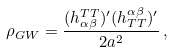<formula> <loc_0><loc_0><loc_500><loc_500>\rho _ { G W } = { \frac { ( h _ { \alpha \beta } ^ { T T } ) ^ { \prime } ( h _ { T T } ^ { \alpha \beta } ) ^ { \prime } } { 2 a ^ { 2 } } } \, ,</formula> 